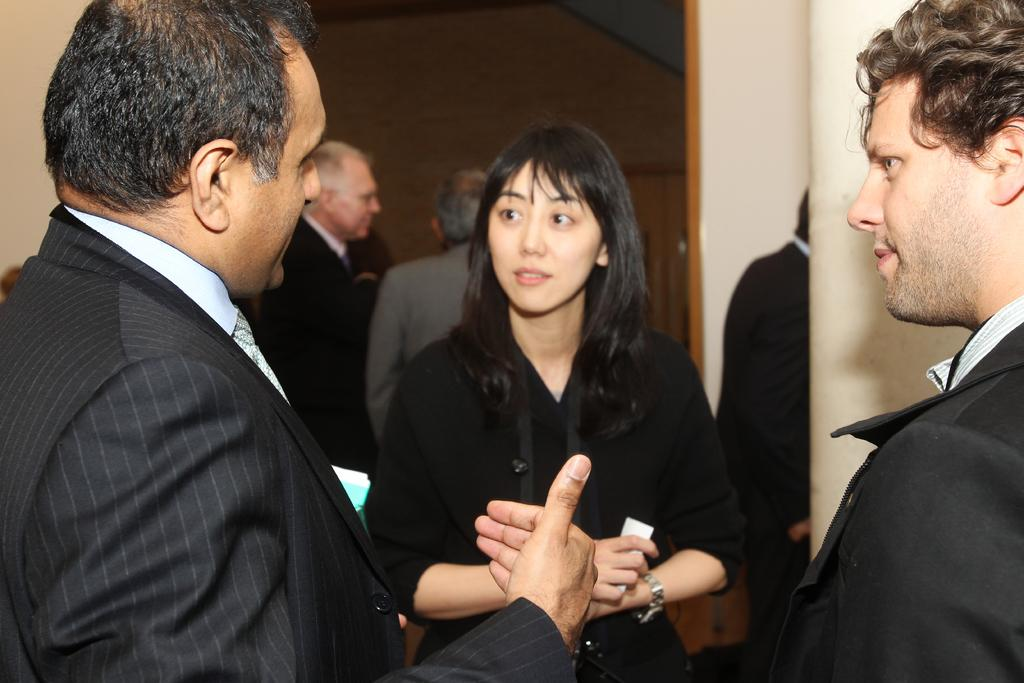What is the main subject of the image? The main subject of the image is a group of people. What are the people in the image doing? The people are standing. What can be seen in the background of the image? There is a wall in the background of the image. What type of polish is being applied to the jewel in the image? There is no polish or jewel present in the image; it features a group of people standing in front of a wall. 